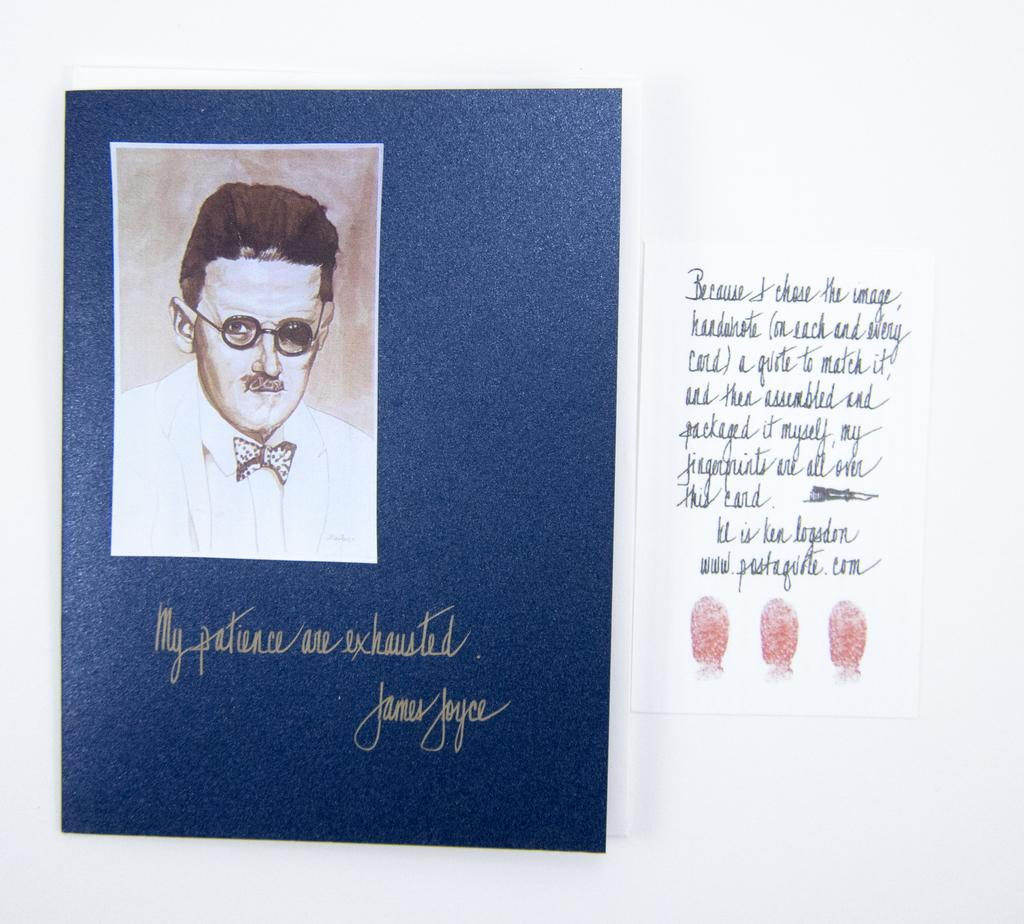What is the main subject of the image? The main subject of the image is a book cover design. Can you describe the photo on the book cover? There is a photo of a person on the left side of the book cover. What else is present on the book cover besides the photo? There is text on the right side of the book cover. What type of plastic material can be seen on the book cover? There is no plastic material present on the book cover; it is a design printed on a surface, likely paper or cardboard. Can you describe the lift featured on the book cover? There is no lift depicted on the book cover; it only contains a photo of a person and text. 